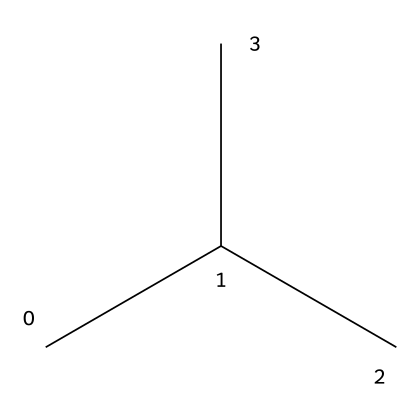What is the molecular formula of isobutane? The SMILES representation CC(C)C indicates that the molecule consists of four carbon atoms (C) and ten hydrogen atoms (H), giving us the molecular formula C4H10.
Answer: C4H10 How many carbon atoms are in isobutane? In the SMILES representation CC(C)C, there are four 'C' characters indicating the presence of four carbon atoms in the structure.
Answer: 4 Is isobutane a straight-chain or branched-chain alkane? The structure CC(C)C shows that the carbon atoms are connected in a branched manner rather than a straight chain, as one carbon is attached to three others.
Answer: branched-chain What type of refrigerant is isobutane classified as? Isobutane is a hydrocarbon refrigerant, indicating that it belongs to the class of hydrocarbons used specifically for refrigeration.
Answer: hydrocarbon How many hydrogen atoms are attached to the terminal carbon atoms in isobutane? In isobutane, each terminal carbon (the outer ones) in the structure CC(C)C has three hydrogen atoms attached to it because they are bonded to one carbon atom and need enough hydrogen to satisfy the tetravalent nature of carbon.
Answer: 3 Is isobutane used in food preservation techniques? Isobutane is indeed utilized in some specialized food preservation methods due to its effectiveness in refrigeration applications.
Answer: yes What is the significance of the structural branching in isobutane? The branching in isobutane contributes to its lower boiling point compared to straight-chain alkanes of the same molecular formula, making it suitable for refrigeration purposes where lower temperatures are required.
Answer: lower boiling point 